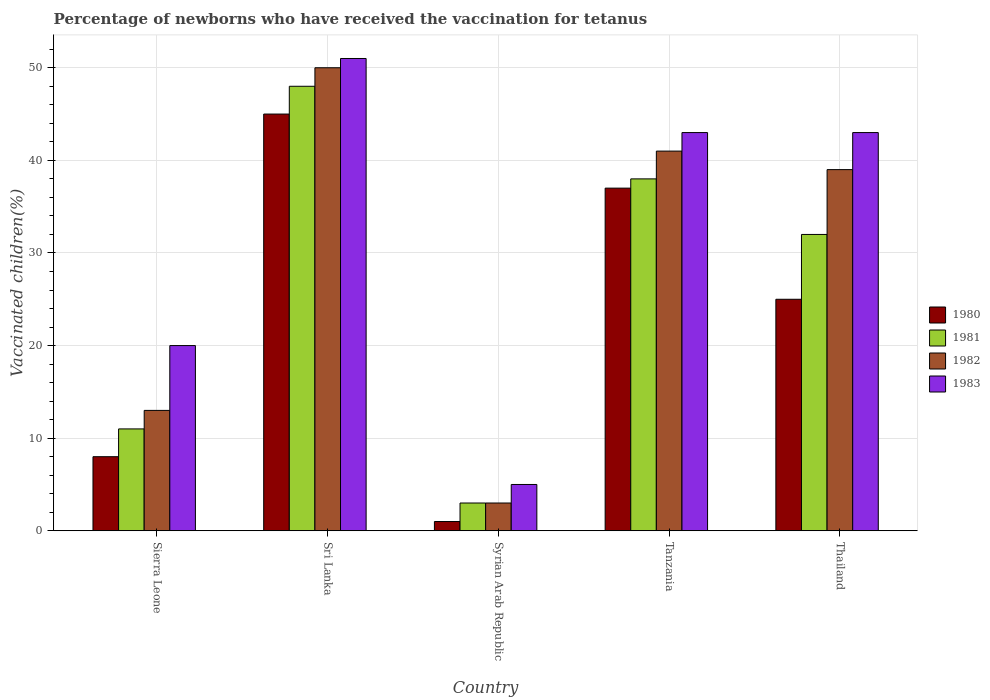How many different coloured bars are there?
Your response must be concise. 4. Are the number of bars per tick equal to the number of legend labels?
Keep it short and to the point. Yes. Are the number of bars on each tick of the X-axis equal?
Offer a very short reply. Yes. How many bars are there on the 3rd tick from the right?
Your answer should be very brief. 4. What is the label of the 1st group of bars from the left?
Keep it short and to the point. Sierra Leone. Across all countries, what is the maximum percentage of vaccinated children in 1982?
Your response must be concise. 50. Across all countries, what is the minimum percentage of vaccinated children in 1983?
Ensure brevity in your answer.  5. In which country was the percentage of vaccinated children in 1983 maximum?
Give a very brief answer. Sri Lanka. In which country was the percentage of vaccinated children in 1983 minimum?
Keep it short and to the point. Syrian Arab Republic. What is the total percentage of vaccinated children in 1981 in the graph?
Offer a very short reply. 132. What is the difference between the percentage of vaccinated children in 1981 in Sri Lanka and that in Tanzania?
Your response must be concise. 10. What is the difference between the percentage of vaccinated children in 1983 in Tanzania and the percentage of vaccinated children in 1982 in Thailand?
Your response must be concise. 4. What is the average percentage of vaccinated children in 1980 per country?
Keep it short and to the point. 23.2. In how many countries, is the percentage of vaccinated children in 1981 greater than 14 %?
Your answer should be compact. 3. What is the ratio of the percentage of vaccinated children in 1983 in Sierra Leone to that in Thailand?
Keep it short and to the point. 0.47. What is the difference between the highest and the lowest percentage of vaccinated children in 1983?
Your response must be concise. 46. In how many countries, is the percentage of vaccinated children in 1982 greater than the average percentage of vaccinated children in 1982 taken over all countries?
Provide a short and direct response. 3. Is the sum of the percentage of vaccinated children in 1983 in Sierra Leone and Sri Lanka greater than the maximum percentage of vaccinated children in 1982 across all countries?
Provide a succinct answer. Yes. Is it the case that in every country, the sum of the percentage of vaccinated children in 1980 and percentage of vaccinated children in 1981 is greater than the sum of percentage of vaccinated children in 1983 and percentage of vaccinated children in 1982?
Give a very brief answer. No. What does the 1st bar from the left in Sri Lanka represents?
Ensure brevity in your answer.  1980. What does the 4th bar from the right in Syrian Arab Republic represents?
Provide a short and direct response. 1980. How many bars are there?
Make the answer very short. 20. Are all the bars in the graph horizontal?
Offer a very short reply. No. What is the difference between two consecutive major ticks on the Y-axis?
Your answer should be very brief. 10. Does the graph contain any zero values?
Keep it short and to the point. No. Where does the legend appear in the graph?
Your answer should be very brief. Center right. How many legend labels are there?
Your response must be concise. 4. What is the title of the graph?
Your answer should be compact. Percentage of newborns who have received the vaccination for tetanus. What is the label or title of the Y-axis?
Provide a short and direct response. Vaccinated children(%). What is the Vaccinated children(%) in 1980 in Sierra Leone?
Give a very brief answer. 8. What is the Vaccinated children(%) in 1981 in Sierra Leone?
Your answer should be compact. 11. What is the Vaccinated children(%) in 1982 in Sierra Leone?
Your answer should be very brief. 13. What is the Vaccinated children(%) of 1981 in Sri Lanka?
Make the answer very short. 48. What is the Vaccinated children(%) of 1980 in Syrian Arab Republic?
Provide a short and direct response. 1. What is the Vaccinated children(%) in 1983 in Syrian Arab Republic?
Offer a very short reply. 5. What is the Vaccinated children(%) in 1983 in Tanzania?
Your answer should be compact. 43. What is the Vaccinated children(%) in 1980 in Thailand?
Provide a short and direct response. 25. What is the Vaccinated children(%) in 1983 in Thailand?
Your answer should be compact. 43. Across all countries, what is the maximum Vaccinated children(%) in 1980?
Ensure brevity in your answer.  45. Across all countries, what is the maximum Vaccinated children(%) in 1981?
Your answer should be compact. 48. Across all countries, what is the minimum Vaccinated children(%) in 1981?
Ensure brevity in your answer.  3. Across all countries, what is the minimum Vaccinated children(%) of 1983?
Provide a short and direct response. 5. What is the total Vaccinated children(%) of 1980 in the graph?
Ensure brevity in your answer.  116. What is the total Vaccinated children(%) in 1981 in the graph?
Your response must be concise. 132. What is the total Vaccinated children(%) in 1982 in the graph?
Make the answer very short. 146. What is the total Vaccinated children(%) in 1983 in the graph?
Provide a succinct answer. 162. What is the difference between the Vaccinated children(%) of 1980 in Sierra Leone and that in Sri Lanka?
Ensure brevity in your answer.  -37. What is the difference between the Vaccinated children(%) of 1981 in Sierra Leone and that in Sri Lanka?
Offer a terse response. -37. What is the difference between the Vaccinated children(%) of 1982 in Sierra Leone and that in Sri Lanka?
Ensure brevity in your answer.  -37. What is the difference between the Vaccinated children(%) of 1983 in Sierra Leone and that in Sri Lanka?
Provide a short and direct response. -31. What is the difference between the Vaccinated children(%) in 1980 in Sierra Leone and that in Syrian Arab Republic?
Ensure brevity in your answer.  7. What is the difference between the Vaccinated children(%) of 1981 in Sierra Leone and that in Syrian Arab Republic?
Ensure brevity in your answer.  8. What is the difference between the Vaccinated children(%) of 1983 in Sierra Leone and that in Syrian Arab Republic?
Ensure brevity in your answer.  15. What is the difference between the Vaccinated children(%) of 1980 in Sierra Leone and that in Tanzania?
Give a very brief answer. -29. What is the difference between the Vaccinated children(%) of 1982 in Sierra Leone and that in Tanzania?
Your answer should be compact. -28. What is the difference between the Vaccinated children(%) in 1983 in Sierra Leone and that in Tanzania?
Make the answer very short. -23. What is the difference between the Vaccinated children(%) of 1980 in Sierra Leone and that in Thailand?
Make the answer very short. -17. What is the difference between the Vaccinated children(%) of 1981 in Sierra Leone and that in Thailand?
Make the answer very short. -21. What is the difference between the Vaccinated children(%) in 1982 in Sierra Leone and that in Thailand?
Your answer should be very brief. -26. What is the difference between the Vaccinated children(%) in 1981 in Sri Lanka and that in Syrian Arab Republic?
Ensure brevity in your answer.  45. What is the difference between the Vaccinated children(%) in 1983 in Sri Lanka and that in Syrian Arab Republic?
Give a very brief answer. 46. What is the difference between the Vaccinated children(%) in 1980 in Sri Lanka and that in Tanzania?
Ensure brevity in your answer.  8. What is the difference between the Vaccinated children(%) of 1981 in Sri Lanka and that in Tanzania?
Keep it short and to the point. 10. What is the difference between the Vaccinated children(%) of 1983 in Sri Lanka and that in Tanzania?
Provide a short and direct response. 8. What is the difference between the Vaccinated children(%) in 1980 in Sri Lanka and that in Thailand?
Give a very brief answer. 20. What is the difference between the Vaccinated children(%) of 1981 in Sri Lanka and that in Thailand?
Ensure brevity in your answer.  16. What is the difference between the Vaccinated children(%) in 1983 in Sri Lanka and that in Thailand?
Offer a terse response. 8. What is the difference between the Vaccinated children(%) in 1980 in Syrian Arab Republic and that in Tanzania?
Your answer should be compact. -36. What is the difference between the Vaccinated children(%) of 1981 in Syrian Arab Republic and that in Tanzania?
Give a very brief answer. -35. What is the difference between the Vaccinated children(%) of 1982 in Syrian Arab Republic and that in Tanzania?
Provide a succinct answer. -38. What is the difference between the Vaccinated children(%) of 1983 in Syrian Arab Republic and that in Tanzania?
Offer a terse response. -38. What is the difference between the Vaccinated children(%) of 1981 in Syrian Arab Republic and that in Thailand?
Provide a short and direct response. -29. What is the difference between the Vaccinated children(%) in 1982 in Syrian Arab Republic and that in Thailand?
Offer a terse response. -36. What is the difference between the Vaccinated children(%) in 1983 in Syrian Arab Republic and that in Thailand?
Your answer should be compact. -38. What is the difference between the Vaccinated children(%) in 1981 in Tanzania and that in Thailand?
Your response must be concise. 6. What is the difference between the Vaccinated children(%) in 1982 in Tanzania and that in Thailand?
Make the answer very short. 2. What is the difference between the Vaccinated children(%) of 1983 in Tanzania and that in Thailand?
Provide a succinct answer. 0. What is the difference between the Vaccinated children(%) of 1980 in Sierra Leone and the Vaccinated children(%) of 1982 in Sri Lanka?
Give a very brief answer. -42. What is the difference between the Vaccinated children(%) in 1980 in Sierra Leone and the Vaccinated children(%) in 1983 in Sri Lanka?
Offer a very short reply. -43. What is the difference between the Vaccinated children(%) in 1981 in Sierra Leone and the Vaccinated children(%) in 1982 in Sri Lanka?
Offer a very short reply. -39. What is the difference between the Vaccinated children(%) of 1982 in Sierra Leone and the Vaccinated children(%) of 1983 in Sri Lanka?
Provide a succinct answer. -38. What is the difference between the Vaccinated children(%) in 1980 in Sierra Leone and the Vaccinated children(%) in 1981 in Syrian Arab Republic?
Provide a succinct answer. 5. What is the difference between the Vaccinated children(%) in 1980 in Sierra Leone and the Vaccinated children(%) in 1982 in Syrian Arab Republic?
Your response must be concise. 5. What is the difference between the Vaccinated children(%) of 1981 in Sierra Leone and the Vaccinated children(%) of 1983 in Syrian Arab Republic?
Provide a succinct answer. 6. What is the difference between the Vaccinated children(%) in 1982 in Sierra Leone and the Vaccinated children(%) in 1983 in Syrian Arab Republic?
Your answer should be very brief. 8. What is the difference between the Vaccinated children(%) in 1980 in Sierra Leone and the Vaccinated children(%) in 1982 in Tanzania?
Provide a succinct answer. -33. What is the difference between the Vaccinated children(%) in 1980 in Sierra Leone and the Vaccinated children(%) in 1983 in Tanzania?
Provide a short and direct response. -35. What is the difference between the Vaccinated children(%) in 1981 in Sierra Leone and the Vaccinated children(%) in 1983 in Tanzania?
Ensure brevity in your answer.  -32. What is the difference between the Vaccinated children(%) in 1982 in Sierra Leone and the Vaccinated children(%) in 1983 in Tanzania?
Provide a short and direct response. -30. What is the difference between the Vaccinated children(%) of 1980 in Sierra Leone and the Vaccinated children(%) of 1982 in Thailand?
Offer a terse response. -31. What is the difference between the Vaccinated children(%) in 1980 in Sierra Leone and the Vaccinated children(%) in 1983 in Thailand?
Offer a very short reply. -35. What is the difference between the Vaccinated children(%) of 1981 in Sierra Leone and the Vaccinated children(%) of 1983 in Thailand?
Your answer should be compact. -32. What is the difference between the Vaccinated children(%) in 1982 in Sierra Leone and the Vaccinated children(%) in 1983 in Thailand?
Keep it short and to the point. -30. What is the difference between the Vaccinated children(%) of 1980 in Sri Lanka and the Vaccinated children(%) of 1981 in Syrian Arab Republic?
Your response must be concise. 42. What is the difference between the Vaccinated children(%) in 1980 in Sri Lanka and the Vaccinated children(%) in 1982 in Syrian Arab Republic?
Provide a short and direct response. 42. What is the difference between the Vaccinated children(%) of 1981 in Sri Lanka and the Vaccinated children(%) of 1983 in Syrian Arab Republic?
Make the answer very short. 43. What is the difference between the Vaccinated children(%) of 1980 in Sri Lanka and the Vaccinated children(%) of 1981 in Tanzania?
Give a very brief answer. 7. What is the difference between the Vaccinated children(%) in 1980 in Sri Lanka and the Vaccinated children(%) in 1982 in Tanzania?
Provide a succinct answer. 4. What is the difference between the Vaccinated children(%) in 1982 in Sri Lanka and the Vaccinated children(%) in 1983 in Tanzania?
Ensure brevity in your answer.  7. What is the difference between the Vaccinated children(%) in 1980 in Sri Lanka and the Vaccinated children(%) in 1981 in Thailand?
Provide a succinct answer. 13. What is the difference between the Vaccinated children(%) of 1980 in Sri Lanka and the Vaccinated children(%) of 1982 in Thailand?
Your response must be concise. 6. What is the difference between the Vaccinated children(%) in 1981 in Sri Lanka and the Vaccinated children(%) in 1983 in Thailand?
Keep it short and to the point. 5. What is the difference between the Vaccinated children(%) of 1982 in Sri Lanka and the Vaccinated children(%) of 1983 in Thailand?
Provide a succinct answer. 7. What is the difference between the Vaccinated children(%) of 1980 in Syrian Arab Republic and the Vaccinated children(%) of 1981 in Tanzania?
Your answer should be very brief. -37. What is the difference between the Vaccinated children(%) of 1980 in Syrian Arab Republic and the Vaccinated children(%) of 1982 in Tanzania?
Provide a succinct answer. -40. What is the difference between the Vaccinated children(%) in 1980 in Syrian Arab Republic and the Vaccinated children(%) in 1983 in Tanzania?
Your answer should be compact. -42. What is the difference between the Vaccinated children(%) of 1981 in Syrian Arab Republic and the Vaccinated children(%) of 1982 in Tanzania?
Your answer should be very brief. -38. What is the difference between the Vaccinated children(%) of 1981 in Syrian Arab Republic and the Vaccinated children(%) of 1983 in Tanzania?
Provide a short and direct response. -40. What is the difference between the Vaccinated children(%) in 1982 in Syrian Arab Republic and the Vaccinated children(%) in 1983 in Tanzania?
Give a very brief answer. -40. What is the difference between the Vaccinated children(%) in 1980 in Syrian Arab Republic and the Vaccinated children(%) in 1981 in Thailand?
Your response must be concise. -31. What is the difference between the Vaccinated children(%) in 1980 in Syrian Arab Republic and the Vaccinated children(%) in 1982 in Thailand?
Your answer should be compact. -38. What is the difference between the Vaccinated children(%) of 1980 in Syrian Arab Republic and the Vaccinated children(%) of 1983 in Thailand?
Your answer should be very brief. -42. What is the difference between the Vaccinated children(%) of 1981 in Syrian Arab Republic and the Vaccinated children(%) of 1982 in Thailand?
Offer a terse response. -36. What is the difference between the Vaccinated children(%) of 1981 in Syrian Arab Republic and the Vaccinated children(%) of 1983 in Thailand?
Keep it short and to the point. -40. What is the difference between the Vaccinated children(%) in 1980 in Tanzania and the Vaccinated children(%) in 1981 in Thailand?
Your answer should be very brief. 5. What is the difference between the Vaccinated children(%) of 1980 in Tanzania and the Vaccinated children(%) of 1982 in Thailand?
Keep it short and to the point. -2. What is the average Vaccinated children(%) of 1980 per country?
Give a very brief answer. 23.2. What is the average Vaccinated children(%) of 1981 per country?
Give a very brief answer. 26.4. What is the average Vaccinated children(%) in 1982 per country?
Your response must be concise. 29.2. What is the average Vaccinated children(%) in 1983 per country?
Ensure brevity in your answer.  32.4. What is the difference between the Vaccinated children(%) of 1980 and Vaccinated children(%) of 1981 in Sierra Leone?
Provide a short and direct response. -3. What is the difference between the Vaccinated children(%) in 1980 and Vaccinated children(%) in 1983 in Sierra Leone?
Provide a succinct answer. -12. What is the difference between the Vaccinated children(%) in 1981 and Vaccinated children(%) in 1983 in Sierra Leone?
Your answer should be compact. -9. What is the difference between the Vaccinated children(%) in 1980 and Vaccinated children(%) in 1981 in Sri Lanka?
Your response must be concise. -3. What is the difference between the Vaccinated children(%) of 1980 and Vaccinated children(%) of 1982 in Sri Lanka?
Give a very brief answer. -5. What is the difference between the Vaccinated children(%) of 1981 and Vaccinated children(%) of 1982 in Sri Lanka?
Offer a terse response. -2. What is the difference between the Vaccinated children(%) in 1982 and Vaccinated children(%) in 1983 in Sri Lanka?
Your answer should be compact. -1. What is the difference between the Vaccinated children(%) of 1980 and Vaccinated children(%) of 1981 in Syrian Arab Republic?
Offer a very short reply. -2. What is the difference between the Vaccinated children(%) in 1980 and Vaccinated children(%) in 1982 in Syrian Arab Republic?
Your answer should be compact. -2. What is the difference between the Vaccinated children(%) of 1980 and Vaccinated children(%) of 1981 in Tanzania?
Your answer should be compact. -1. What is the difference between the Vaccinated children(%) of 1980 and Vaccinated children(%) of 1983 in Tanzania?
Give a very brief answer. -6. What is the difference between the Vaccinated children(%) in 1980 and Vaccinated children(%) in 1981 in Thailand?
Your answer should be compact. -7. What is the difference between the Vaccinated children(%) in 1980 and Vaccinated children(%) in 1982 in Thailand?
Keep it short and to the point. -14. What is the difference between the Vaccinated children(%) in 1980 and Vaccinated children(%) in 1983 in Thailand?
Your response must be concise. -18. What is the difference between the Vaccinated children(%) of 1981 and Vaccinated children(%) of 1982 in Thailand?
Your answer should be very brief. -7. What is the ratio of the Vaccinated children(%) in 1980 in Sierra Leone to that in Sri Lanka?
Provide a succinct answer. 0.18. What is the ratio of the Vaccinated children(%) in 1981 in Sierra Leone to that in Sri Lanka?
Your answer should be very brief. 0.23. What is the ratio of the Vaccinated children(%) of 1982 in Sierra Leone to that in Sri Lanka?
Your answer should be very brief. 0.26. What is the ratio of the Vaccinated children(%) in 1983 in Sierra Leone to that in Sri Lanka?
Your response must be concise. 0.39. What is the ratio of the Vaccinated children(%) in 1981 in Sierra Leone to that in Syrian Arab Republic?
Provide a succinct answer. 3.67. What is the ratio of the Vaccinated children(%) of 1982 in Sierra Leone to that in Syrian Arab Republic?
Your response must be concise. 4.33. What is the ratio of the Vaccinated children(%) of 1980 in Sierra Leone to that in Tanzania?
Your answer should be very brief. 0.22. What is the ratio of the Vaccinated children(%) in 1981 in Sierra Leone to that in Tanzania?
Your answer should be compact. 0.29. What is the ratio of the Vaccinated children(%) in 1982 in Sierra Leone to that in Tanzania?
Give a very brief answer. 0.32. What is the ratio of the Vaccinated children(%) in 1983 in Sierra Leone to that in Tanzania?
Ensure brevity in your answer.  0.47. What is the ratio of the Vaccinated children(%) in 1980 in Sierra Leone to that in Thailand?
Provide a succinct answer. 0.32. What is the ratio of the Vaccinated children(%) in 1981 in Sierra Leone to that in Thailand?
Ensure brevity in your answer.  0.34. What is the ratio of the Vaccinated children(%) in 1983 in Sierra Leone to that in Thailand?
Make the answer very short. 0.47. What is the ratio of the Vaccinated children(%) of 1980 in Sri Lanka to that in Syrian Arab Republic?
Offer a very short reply. 45. What is the ratio of the Vaccinated children(%) in 1982 in Sri Lanka to that in Syrian Arab Republic?
Give a very brief answer. 16.67. What is the ratio of the Vaccinated children(%) in 1980 in Sri Lanka to that in Tanzania?
Keep it short and to the point. 1.22. What is the ratio of the Vaccinated children(%) of 1981 in Sri Lanka to that in Tanzania?
Your response must be concise. 1.26. What is the ratio of the Vaccinated children(%) of 1982 in Sri Lanka to that in Tanzania?
Offer a very short reply. 1.22. What is the ratio of the Vaccinated children(%) in 1983 in Sri Lanka to that in Tanzania?
Ensure brevity in your answer.  1.19. What is the ratio of the Vaccinated children(%) in 1981 in Sri Lanka to that in Thailand?
Ensure brevity in your answer.  1.5. What is the ratio of the Vaccinated children(%) of 1982 in Sri Lanka to that in Thailand?
Your answer should be compact. 1.28. What is the ratio of the Vaccinated children(%) in 1983 in Sri Lanka to that in Thailand?
Keep it short and to the point. 1.19. What is the ratio of the Vaccinated children(%) in 1980 in Syrian Arab Republic to that in Tanzania?
Your response must be concise. 0.03. What is the ratio of the Vaccinated children(%) in 1981 in Syrian Arab Republic to that in Tanzania?
Your answer should be very brief. 0.08. What is the ratio of the Vaccinated children(%) in 1982 in Syrian Arab Republic to that in Tanzania?
Make the answer very short. 0.07. What is the ratio of the Vaccinated children(%) in 1983 in Syrian Arab Republic to that in Tanzania?
Give a very brief answer. 0.12. What is the ratio of the Vaccinated children(%) in 1980 in Syrian Arab Republic to that in Thailand?
Make the answer very short. 0.04. What is the ratio of the Vaccinated children(%) in 1981 in Syrian Arab Republic to that in Thailand?
Provide a short and direct response. 0.09. What is the ratio of the Vaccinated children(%) of 1982 in Syrian Arab Republic to that in Thailand?
Ensure brevity in your answer.  0.08. What is the ratio of the Vaccinated children(%) of 1983 in Syrian Arab Republic to that in Thailand?
Keep it short and to the point. 0.12. What is the ratio of the Vaccinated children(%) in 1980 in Tanzania to that in Thailand?
Ensure brevity in your answer.  1.48. What is the ratio of the Vaccinated children(%) of 1981 in Tanzania to that in Thailand?
Give a very brief answer. 1.19. What is the ratio of the Vaccinated children(%) of 1982 in Tanzania to that in Thailand?
Offer a very short reply. 1.05. What is the difference between the highest and the second highest Vaccinated children(%) of 1980?
Provide a succinct answer. 8. What is the difference between the highest and the second highest Vaccinated children(%) in 1983?
Your answer should be very brief. 8. What is the difference between the highest and the lowest Vaccinated children(%) of 1981?
Make the answer very short. 45. 